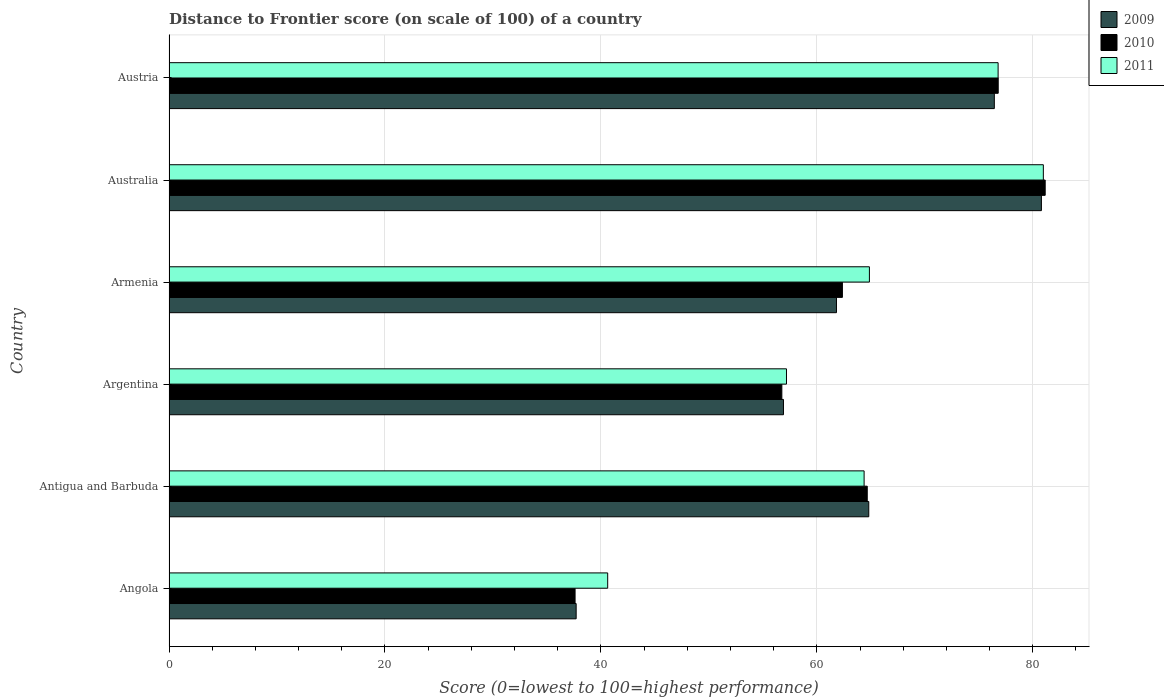How many groups of bars are there?
Keep it short and to the point. 6. What is the distance to frontier score of in 2009 in Armenia?
Your response must be concise. 61.82. Across all countries, what is the maximum distance to frontier score of in 2011?
Offer a terse response. 80.98. Across all countries, what is the minimum distance to frontier score of in 2009?
Offer a very short reply. 37.71. In which country was the distance to frontier score of in 2010 maximum?
Offer a very short reply. Australia. In which country was the distance to frontier score of in 2011 minimum?
Your answer should be compact. Angola. What is the total distance to frontier score of in 2011 in the graph?
Your answer should be compact. 384.84. What is the difference between the distance to frontier score of in 2011 in Angola and that in Antigua and Barbuda?
Give a very brief answer. -23.75. What is the difference between the distance to frontier score of in 2011 in Argentina and the distance to frontier score of in 2009 in Armenia?
Keep it short and to the point. -4.63. What is the average distance to frontier score of in 2009 per country?
Provide a short and direct response. 63.08. What is the difference between the distance to frontier score of in 2010 and distance to frontier score of in 2009 in Argentina?
Your response must be concise. -0.15. What is the ratio of the distance to frontier score of in 2011 in Antigua and Barbuda to that in Armenia?
Offer a very short reply. 0.99. Is the distance to frontier score of in 2011 in Armenia less than that in Austria?
Offer a terse response. Yes. Is the difference between the distance to frontier score of in 2010 in Angola and Armenia greater than the difference between the distance to frontier score of in 2009 in Angola and Armenia?
Keep it short and to the point. No. What is the difference between the highest and the second highest distance to frontier score of in 2009?
Your answer should be compact. 4.36. What is the difference between the highest and the lowest distance to frontier score of in 2011?
Ensure brevity in your answer.  40.35. In how many countries, is the distance to frontier score of in 2009 greater than the average distance to frontier score of in 2009 taken over all countries?
Your answer should be compact. 3. What does the 1st bar from the top in Angola represents?
Offer a very short reply. 2011. How many countries are there in the graph?
Make the answer very short. 6. What is the difference between two consecutive major ticks on the X-axis?
Keep it short and to the point. 20. Are the values on the major ticks of X-axis written in scientific E-notation?
Offer a terse response. No. Does the graph contain any zero values?
Ensure brevity in your answer.  No. What is the title of the graph?
Offer a terse response. Distance to Frontier score (on scale of 100) of a country. What is the label or title of the X-axis?
Provide a succinct answer. Score (0=lowest to 100=highest performance). What is the Score (0=lowest to 100=highest performance) of 2009 in Angola?
Keep it short and to the point. 37.71. What is the Score (0=lowest to 100=highest performance) in 2010 in Angola?
Your answer should be very brief. 37.61. What is the Score (0=lowest to 100=highest performance) in 2011 in Angola?
Make the answer very short. 40.63. What is the Score (0=lowest to 100=highest performance) of 2009 in Antigua and Barbuda?
Give a very brief answer. 64.81. What is the Score (0=lowest to 100=highest performance) of 2010 in Antigua and Barbuda?
Give a very brief answer. 64.67. What is the Score (0=lowest to 100=highest performance) in 2011 in Antigua and Barbuda?
Your answer should be very brief. 64.38. What is the Score (0=lowest to 100=highest performance) of 2009 in Argentina?
Offer a very short reply. 56.91. What is the Score (0=lowest to 100=highest performance) of 2010 in Argentina?
Your answer should be compact. 56.76. What is the Score (0=lowest to 100=highest performance) in 2011 in Argentina?
Your response must be concise. 57.19. What is the Score (0=lowest to 100=highest performance) in 2009 in Armenia?
Your answer should be compact. 61.82. What is the Score (0=lowest to 100=highest performance) in 2010 in Armenia?
Provide a short and direct response. 62.37. What is the Score (0=lowest to 100=highest performance) of 2011 in Armenia?
Provide a succinct answer. 64.87. What is the Score (0=lowest to 100=highest performance) in 2009 in Australia?
Offer a terse response. 80.8. What is the Score (0=lowest to 100=highest performance) of 2010 in Australia?
Ensure brevity in your answer.  81.15. What is the Score (0=lowest to 100=highest performance) of 2011 in Australia?
Your answer should be very brief. 80.98. What is the Score (0=lowest to 100=highest performance) in 2009 in Austria?
Offer a terse response. 76.44. What is the Score (0=lowest to 100=highest performance) of 2010 in Austria?
Ensure brevity in your answer.  76.8. What is the Score (0=lowest to 100=highest performance) in 2011 in Austria?
Make the answer very short. 76.79. Across all countries, what is the maximum Score (0=lowest to 100=highest performance) in 2009?
Offer a very short reply. 80.8. Across all countries, what is the maximum Score (0=lowest to 100=highest performance) of 2010?
Make the answer very short. 81.15. Across all countries, what is the maximum Score (0=lowest to 100=highest performance) in 2011?
Provide a succinct answer. 80.98. Across all countries, what is the minimum Score (0=lowest to 100=highest performance) of 2009?
Offer a very short reply. 37.71. Across all countries, what is the minimum Score (0=lowest to 100=highest performance) in 2010?
Ensure brevity in your answer.  37.61. Across all countries, what is the minimum Score (0=lowest to 100=highest performance) in 2011?
Offer a very short reply. 40.63. What is the total Score (0=lowest to 100=highest performance) in 2009 in the graph?
Keep it short and to the point. 378.49. What is the total Score (0=lowest to 100=highest performance) of 2010 in the graph?
Your response must be concise. 379.36. What is the total Score (0=lowest to 100=highest performance) of 2011 in the graph?
Offer a terse response. 384.84. What is the difference between the Score (0=lowest to 100=highest performance) in 2009 in Angola and that in Antigua and Barbuda?
Your answer should be compact. -27.1. What is the difference between the Score (0=lowest to 100=highest performance) of 2010 in Angola and that in Antigua and Barbuda?
Make the answer very short. -27.06. What is the difference between the Score (0=lowest to 100=highest performance) of 2011 in Angola and that in Antigua and Barbuda?
Provide a short and direct response. -23.75. What is the difference between the Score (0=lowest to 100=highest performance) of 2009 in Angola and that in Argentina?
Your answer should be very brief. -19.2. What is the difference between the Score (0=lowest to 100=highest performance) in 2010 in Angola and that in Argentina?
Give a very brief answer. -19.15. What is the difference between the Score (0=lowest to 100=highest performance) in 2011 in Angola and that in Argentina?
Provide a succinct answer. -16.56. What is the difference between the Score (0=lowest to 100=highest performance) in 2009 in Angola and that in Armenia?
Provide a short and direct response. -24.11. What is the difference between the Score (0=lowest to 100=highest performance) of 2010 in Angola and that in Armenia?
Give a very brief answer. -24.76. What is the difference between the Score (0=lowest to 100=highest performance) in 2011 in Angola and that in Armenia?
Your response must be concise. -24.24. What is the difference between the Score (0=lowest to 100=highest performance) in 2009 in Angola and that in Australia?
Offer a very short reply. -43.09. What is the difference between the Score (0=lowest to 100=highest performance) in 2010 in Angola and that in Australia?
Your answer should be compact. -43.54. What is the difference between the Score (0=lowest to 100=highest performance) in 2011 in Angola and that in Australia?
Ensure brevity in your answer.  -40.35. What is the difference between the Score (0=lowest to 100=highest performance) of 2009 in Angola and that in Austria?
Your response must be concise. -38.73. What is the difference between the Score (0=lowest to 100=highest performance) of 2010 in Angola and that in Austria?
Provide a short and direct response. -39.19. What is the difference between the Score (0=lowest to 100=highest performance) in 2011 in Angola and that in Austria?
Your response must be concise. -36.16. What is the difference between the Score (0=lowest to 100=highest performance) in 2010 in Antigua and Barbuda and that in Argentina?
Your answer should be very brief. 7.91. What is the difference between the Score (0=lowest to 100=highest performance) of 2011 in Antigua and Barbuda and that in Argentina?
Your response must be concise. 7.19. What is the difference between the Score (0=lowest to 100=highest performance) of 2009 in Antigua and Barbuda and that in Armenia?
Keep it short and to the point. 2.99. What is the difference between the Score (0=lowest to 100=highest performance) in 2010 in Antigua and Barbuda and that in Armenia?
Provide a succinct answer. 2.3. What is the difference between the Score (0=lowest to 100=highest performance) in 2011 in Antigua and Barbuda and that in Armenia?
Offer a very short reply. -0.49. What is the difference between the Score (0=lowest to 100=highest performance) in 2009 in Antigua and Barbuda and that in Australia?
Provide a short and direct response. -15.99. What is the difference between the Score (0=lowest to 100=highest performance) in 2010 in Antigua and Barbuda and that in Australia?
Provide a succinct answer. -16.48. What is the difference between the Score (0=lowest to 100=highest performance) of 2011 in Antigua and Barbuda and that in Australia?
Make the answer very short. -16.6. What is the difference between the Score (0=lowest to 100=highest performance) of 2009 in Antigua and Barbuda and that in Austria?
Make the answer very short. -11.63. What is the difference between the Score (0=lowest to 100=highest performance) of 2010 in Antigua and Barbuda and that in Austria?
Your answer should be compact. -12.13. What is the difference between the Score (0=lowest to 100=highest performance) in 2011 in Antigua and Barbuda and that in Austria?
Provide a short and direct response. -12.41. What is the difference between the Score (0=lowest to 100=highest performance) in 2009 in Argentina and that in Armenia?
Your answer should be compact. -4.91. What is the difference between the Score (0=lowest to 100=highest performance) of 2010 in Argentina and that in Armenia?
Your response must be concise. -5.61. What is the difference between the Score (0=lowest to 100=highest performance) of 2011 in Argentina and that in Armenia?
Make the answer very short. -7.68. What is the difference between the Score (0=lowest to 100=highest performance) in 2009 in Argentina and that in Australia?
Provide a short and direct response. -23.89. What is the difference between the Score (0=lowest to 100=highest performance) of 2010 in Argentina and that in Australia?
Provide a succinct answer. -24.39. What is the difference between the Score (0=lowest to 100=highest performance) of 2011 in Argentina and that in Australia?
Keep it short and to the point. -23.79. What is the difference between the Score (0=lowest to 100=highest performance) of 2009 in Argentina and that in Austria?
Offer a very short reply. -19.53. What is the difference between the Score (0=lowest to 100=highest performance) in 2010 in Argentina and that in Austria?
Your answer should be very brief. -20.04. What is the difference between the Score (0=lowest to 100=highest performance) of 2011 in Argentina and that in Austria?
Provide a succinct answer. -19.6. What is the difference between the Score (0=lowest to 100=highest performance) in 2009 in Armenia and that in Australia?
Your answer should be very brief. -18.98. What is the difference between the Score (0=lowest to 100=highest performance) in 2010 in Armenia and that in Australia?
Keep it short and to the point. -18.78. What is the difference between the Score (0=lowest to 100=highest performance) of 2011 in Armenia and that in Australia?
Your response must be concise. -16.11. What is the difference between the Score (0=lowest to 100=highest performance) of 2009 in Armenia and that in Austria?
Your answer should be compact. -14.62. What is the difference between the Score (0=lowest to 100=highest performance) in 2010 in Armenia and that in Austria?
Provide a succinct answer. -14.43. What is the difference between the Score (0=lowest to 100=highest performance) in 2011 in Armenia and that in Austria?
Ensure brevity in your answer.  -11.92. What is the difference between the Score (0=lowest to 100=highest performance) of 2009 in Australia and that in Austria?
Provide a succinct answer. 4.36. What is the difference between the Score (0=lowest to 100=highest performance) in 2010 in Australia and that in Austria?
Your answer should be very brief. 4.35. What is the difference between the Score (0=lowest to 100=highest performance) in 2011 in Australia and that in Austria?
Provide a short and direct response. 4.19. What is the difference between the Score (0=lowest to 100=highest performance) in 2009 in Angola and the Score (0=lowest to 100=highest performance) in 2010 in Antigua and Barbuda?
Your answer should be very brief. -26.96. What is the difference between the Score (0=lowest to 100=highest performance) of 2009 in Angola and the Score (0=lowest to 100=highest performance) of 2011 in Antigua and Barbuda?
Give a very brief answer. -26.67. What is the difference between the Score (0=lowest to 100=highest performance) of 2010 in Angola and the Score (0=lowest to 100=highest performance) of 2011 in Antigua and Barbuda?
Offer a terse response. -26.77. What is the difference between the Score (0=lowest to 100=highest performance) in 2009 in Angola and the Score (0=lowest to 100=highest performance) in 2010 in Argentina?
Make the answer very short. -19.05. What is the difference between the Score (0=lowest to 100=highest performance) of 2009 in Angola and the Score (0=lowest to 100=highest performance) of 2011 in Argentina?
Give a very brief answer. -19.48. What is the difference between the Score (0=lowest to 100=highest performance) of 2010 in Angola and the Score (0=lowest to 100=highest performance) of 2011 in Argentina?
Give a very brief answer. -19.58. What is the difference between the Score (0=lowest to 100=highest performance) in 2009 in Angola and the Score (0=lowest to 100=highest performance) in 2010 in Armenia?
Provide a succinct answer. -24.66. What is the difference between the Score (0=lowest to 100=highest performance) in 2009 in Angola and the Score (0=lowest to 100=highest performance) in 2011 in Armenia?
Offer a terse response. -27.16. What is the difference between the Score (0=lowest to 100=highest performance) in 2010 in Angola and the Score (0=lowest to 100=highest performance) in 2011 in Armenia?
Offer a terse response. -27.26. What is the difference between the Score (0=lowest to 100=highest performance) of 2009 in Angola and the Score (0=lowest to 100=highest performance) of 2010 in Australia?
Offer a very short reply. -43.44. What is the difference between the Score (0=lowest to 100=highest performance) of 2009 in Angola and the Score (0=lowest to 100=highest performance) of 2011 in Australia?
Keep it short and to the point. -43.27. What is the difference between the Score (0=lowest to 100=highest performance) in 2010 in Angola and the Score (0=lowest to 100=highest performance) in 2011 in Australia?
Make the answer very short. -43.37. What is the difference between the Score (0=lowest to 100=highest performance) of 2009 in Angola and the Score (0=lowest to 100=highest performance) of 2010 in Austria?
Ensure brevity in your answer.  -39.09. What is the difference between the Score (0=lowest to 100=highest performance) in 2009 in Angola and the Score (0=lowest to 100=highest performance) in 2011 in Austria?
Your answer should be compact. -39.08. What is the difference between the Score (0=lowest to 100=highest performance) in 2010 in Angola and the Score (0=lowest to 100=highest performance) in 2011 in Austria?
Ensure brevity in your answer.  -39.18. What is the difference between the Score (0=lowest to 100=highest performance) in 2009 in Antigua and Barbuda and the Score (0=lowest to 100=highest performance) in 2010 in Argentina?
Give a very brief answer. 8.05. What is the difference between the Score (0=lowest to 100=highest performance) in 2009 in Antigua and Barbuda and the Score (0=lowest to 100=highest performance) in 2011 in Argentina?
Provide a succinct answer. 7.62. What is the difference between the Score (0=lowest to 100=highest performance) of 2010 in Antigua and Barbuda and the Score (0=lowest to 100=highest performance) of 2011 in Argentina?
Give a very brief answer. 7.48. What is the difference between the Score (0=lowest to 100=highest performance) of 2009 in Antigua and Barbuda and the Score (0=lowest to 100=highest performance) of 2010 in Armenia?
Keep it short and to the point. 2.44. What is the difference between the Score (0=lowest to 100=highest performance) of 2009 in Antigua and Barbuda and the Score (0=lowest to 100=highest performance) of 2011 in Armenia?
Give a very brief answer. -0.06. What is the difference between the Score (0=lowest to 100=highest performance) in 2010 in Antigua and Barbuda and the Score (0=lowest to 100=highest performance) in 2011 in Armenia?
Ensure brevity in your answer.  -0.2. What is the difference between the Score (0=lowest to 100=highest performance) in 2009 in Antigua and Barbuda and the Score (0=lowest to 100=highest performance) in 2010 in Australia?
Offer a very short reply. -16.34. What is the difference between the Score (0=lowest to 100=highest performance) in 2009 in Antigua and Barbuda and the Score (0=lowest to 100=highest performance) in 2011 in Australia?
Make the answer very short. -16.17. What is the difference between the Score (0=lowest to 100=highest performance) of 2010 in Antigua and Barbuda and the Score (0=lowest to 100=highest performance) of 2011 in Australia?
Provide a short and direct response. -16.31. What is the difference between the Score (0=lowest to 100=highest performance) of 2009 in Antigua and Barbuda and the Score (0=lowest to 100=highest performance) of 2010 in Austria?
Provide a succinct answer. -11.99. What is the difference between the Score (0=lowest to 100=highest performance) of 2009 in Antigua and Barbuda and the Score (0=lowest to 100=highest performance) of 2011 in Austria?
Ensure brevity in your answer.  -11.98. What is the difference between the Score (0=lowest to 100=highest performance) of 2010 in Antigua and Barbuda and the Score (0=lowest to 100=highest performance) of 2011 in Austria?
Provide a succinct answer. -12.12. What is the difference between the Score (0=lowest to 100=highest performance) of 2009 in Argentina and the Score (0=lowest to 100=highest performance) of 2010 in Armenia?
Make the answer very short. -5.46. What is the difference between the Score (0=lowest to 100=highest performance) in 2009 in Argentina and the Score (0=lowest to 100=highest performance) in 2011 in Armenia?
Your answer should be very brief. -7.96. What is the difference between the Score (0=lowest to 100=highest performance) in 2010 in Argentina and the Score (0=lowest to 100=highest performance) in 2011 in Armenia?
Offer a terse response. -8.11. What is the difference between the Score (0=lowest to 100=highest performance) of 2009 in Argentina and the Score (0=lowest to 100=highest performance) of 2010 in Australia?
Keep it short and to the point. -24.24. What is the difference between the Score (0=lowest to 100=highest performance) of 2009 in Argentina and the Score (0=lowest to 100=highest performance) of 2011 in Australia?
Keep it short and to the point. -24.07. What is the difference between the Score (0=lowest to 100=highest performance) in 2010 in Argentina and the Score (0=lowest to 100=highest performance) in 2011 in Australia?
Provide a succinct answer. -24.22. What is the difference between the Score (0=lowest to 100=highest performance) of 2009 in Argentina and the Score (0=lowest to 100=highest performance) of 2010 in Austria?
Keep it short and to the point. -19.89. What is the difference between the Score (0=lowest to 100=highest performance) in 2009 in Argentina and the Score (0=lowest to 100=highest performance) in 2011 in Austria?
Give a very brief answer. -19.88. What is the difference between the Score (0=lowest to 100=highest performance) in 2010 in Argentina and the Score (0=lowest to 100=highest performance) in 2011 in Austria?
Keep it short and to the point. -20.03. What is the difference between the Score (0=lowest to 100=highest performance) in 2009 in Armenia and the Score (0=lowest to 100=highest performance) in 2010 in Australia?
Offer a very short reply. -19.33. What is the difference between the Score (0=lowest to 100=highest performance) in 2009 in Armenia and the Score (0=lowest to 100=highest performance) in 2011 in Australia?
Provide a succinct answer. -19.16. What is the difference between the Score (0=lowest to 100=highest performance) in 2010 in Armenia and the Score (0=lowest to 100=highest performance) in 2011 in Australia?
Offer a very short reply. -18.61. What is the difference between the Score (0=lowest to 100=highest performance) in 2009 in Armenia and the Score (0=lowest to 100=highest performance) in 2010 in Austria?
Provide a succinct answer. -14.98. What is the difference between the Score (0=lowest to 100=highest performance) of 2009 in Armenia and the Score (0=lowest to 100=highest performance) of 2011 in Austria?
Keep it short and to the point. -14.97. What is the difference between the Score (0=lowest to 100=highest performance) in 2010 in Armenia and the Score (0=lowest to 100=highest performance) in 2011 in Austria?
Offer a terse response. -14.42. What is the difference between the Score (0=lowest to 100=highest performance) of 2009 in Australia and the Score (0=lowest to 100=highest performance) of 2011 in Austria?
Make the answer very short. 4.01. What is the difference between the Score (0=lowest to 100=highest performance) in 2010 in Australia and the Score (0=lowest to 100=highest performance) in 2011 in Austria?
Offer a terse response. 4.36. What is the average Score (0=lowest to 100=highest performance) of 2009 per country?
Provide a short and direct response. 63.08. What is the average Score (0=lowest to 100=highest performance) in 2010 per country?
Give a very brief answer. 63.23. What is the average Score (0=lowest to 100=highest performance) in 2011 per country?
Your answer should be compact. 64.14. What is the difference between the Score (0=lowest to 100=highest performance) of 2009 and Score (0=lowest to 100=highest performance) of 2011 in Angola?
Your answer should be compact. -2.92. What is the difference between the Score (0=lowest to 100=highest performance) of 2010 and Score (0=lowest to 100=highest performance) of 2011 in Angola?
Ensure brevity in your answer.  -3.02. What is the difference between the Score (0=lowest to 100=highest performance) of 2009 and Score (0=lowest to 100=highest performance) of 2010 in Antigua and Barbuda?
Offer a terse response. 0.14. What is the difference between the Score (0=lowest to 100=highest performance) in 2009 and Score (0=lowest to 100=highest performance) in 2011 in Antigua and Barbuda?
Your response must be concise. 0.43. What is the difference between the Score (0=lowest to 100=highest performance) in 2010 and Score (0=lowest to 100=highest performance) in 2011 in Antigua and Barbuda?
Give a very brief answer. 0.29. What is the difference between the Score (0=lowest to 100=highest performance) of 2009 and Score (0=lowest to 100=highest performance) of 2010 in Argentina?
Your response must be concise. 0.15. What is the difference between the Score (0=lowest to 100=highest performance) of 2009 and Score (0=lowest to 100=highest performance) of 2011 in Argentina?
Your answer should be very brief. -0.28. What is the difference between the Score (0=lowest to 100=highest performance) in 2010 and Score (0=lowest to 100=highest performance) in 2011 in Argentina?
Give a very brief answer. -0.43. What is the difference between the Score (0=lowest to 100=highest performance) of 2009 and Score (0=lowest to 100=highest performance) of 2010 in Armenia?
Give a very brief answer. -0.55. What is the difference between the Score (0=lowest to 100=highest performance) of 2009 and Score (0=lowest to 100=highest performance) of 2011 in Armenia?
Give a very brief answer. -3.05. What is the difference between the Score (0=lowest to 100=highest performance) in 2009 and Score (0=lowest to 100=highest performance) in 2010 in Australia?
Make the answer very short. -0.35. What is the difference between the Score (0=lowest to 100=highest performance) in 2009 and Score (0=lowest to 100=highest performance) in 2011 in Australia?
Offer a terse response. -0.18. What is the difference between the Score (0=lowest to 100=highest performance) of 2010 and Score (0=lowest to 100=highest performance) of 2011 in Australia?
Your response must be concise. 0.17. What is the difference between the Score (0=lowest to 100=highest performance) of 2009 and Score (0=lowest to 100=highest performance) of 2010 in Austria?
Offer a very short reply. -0.36. What is the difference between the Score (0=lowest to 100=highest performance) in 2009 and Score (0=lowest to 100=highest performance) in 2011 in Austria?
Provide a succinct answer. -0.35. What is the difference between the Score (0=lowest to 100=highest performance) in 2010 and Score (0=lowest to 100=highest performance) in 2011 in Austria?
Ensure brevity in your answer.  0.01. What is the ratio of the Score (0=lowest to 100=highest performance) of 2009 in Angola to that in Antigua and Barbuda?
Your answer should be very brief. 0.58. What is the ratio of the Score (0=lowest to 100=highest performance) of 2010 in Angola to that in Antigua and Barbuda?
Offer a very short reply. 0.58. What is the ratio of the Score (0=lowest to 100=highest performance) in 2011 in Angola to that in Antigua and Barbuda?
Offer a terse response. 0.63. What is the ratio of the Score (0=lowest to 100=highest performance) in 2009 in Angola to that in Argentina?
Give a very brief answer. 0.66. What is the ratio of the Score (0=lowest to 100=highest performance) in 2010 in Angola to that in Argentina?
Give a very brief answer. 0.66. What is the ratio of the Score (0=lowest to 100=highest performance) in 2011 in Angola to that in Argentina?
Give a very brief answer. 0.71. What is the ratio of the Score (0=lowest to 100=highest performance) in 2009 in Angola to that in Armenia?
Provide a short and direct response. 0.61. What is the ratio of the Score (0=lowest to 100=highest performance) in 2010 in Angola to that in Armenia?
Keep it short and to the point. 0.6. What is the ratio of the Score (0=lowest to 100=highest performance) in 2011 in Angola to that in Armenia?
Ensure brevity in your answer.  0.63. What is the ratio of the Score (0=lowest to 100=highest performance) of 2009 in Angola to that in Australia?
Offer a very short reply. 0.47. What is the ratio of the Score (0=lowest to 100=highest performance) of 2010 in Angola to that in Australia?
Offer a very short reply. 0.46. What is the ratio of the Score (0=lowest to 100=highest performance) in 2011 in Angola to that in Australia?
Provide a succinct answer. 0.5. What is the ratio of the Score (0=lowest to 100=highest performance) of 2009 in Angola to that in Austria?
Offer a very short reply. 0.49. What is the ratio of the Score (0=lowest to 100=highest performance) in 2010 in Angola to that in Austria?
Offer a terse response. 0.49. What is the ratio of the Score (0=lowest to 100=highest performance) of 2011 in Angola to that in Austria?
Keep it short and to the point. 0.53. What is the ratio of the Score (0=lowest to 100=highest performance) of 2009 in Antigua and Barbuda to that in Argentina?
Provide a succinct answer. 1.14. What is the ratio of the Score (0=lowest to 100=highest performance) in 2010 in Antigua and Barbuda to that in Argentina?
Your response must be concise. 1.14. What is the ratio of the Score (0=lowest to 100=highest performance) of 2011 in Antigua and Barbuda to that in Argentina?
Your answer should be very brief. 1.13. What is the ratio of the Score (0=lowest to 100=highest performance) in 2009 in Antigua and Barbuda to that in Armenia?
Your answer should be very brief. 1.05. What is the ratio of the Score (0=lowest to 100=highest performance) of 2010 in Antigua and Barbuda to that in Armenia?
Your answer should be very brief. 1.04. What is the ratio of the Score (0=lowest to 100=highest performance) of 2011 in Antigua and Barbuda to that in Armenia?
Offer a terse response. 0.99. What is the ratio of the Score (0=lowest to 100=highest performance) in 2009 in Antigua and Barbuda to that in Australia?
Ensure brevity in your answer.  0.8. What is the ratio of the Score (0=lowest to 100=highest performance) in 2010 in Antigua and Barbuda to that in Australia?
Offer a very short reply. 0.8. What is the ratio of the Score (0=lowest to 100=highest performance) in 2011 in Antigua and Barbuda to that in Australia?
Ensure brevity in your answer.  0.8. What is the ratio of the Score (0=lowest to 100=highest performance) in 2009 in Antigua and Barbuda to that in Austria?
Ensure brevity in your answer.  0.85. What is the ratio of the Score (0=lowest to 100=highest performance) in 2010 in Antigua and Barbuda to that in Austria?
Offer a very short reply. 0.84. What is the ratio of the Score (0=lowest to 100=highest performance) in 2011 in Antigua and Barbuda to that in Austria?
Your answer should be compact. 0.84. What is the ratio of the Score (0=lowest to 100=highest performance) in 2009 in Argentina to that in Armenia?
Your answer should be compact. 0.92. What is the ratio of the Score (0=lowest to 100=highest performance) in 2010 in Argentina to that in Armenia?
Ensure brevity in your answer.  0.91. What is the ratio of the Score (0=lowest to 100=highest performance) in 2011 in Argentina to that in Armenia?
Make the answer very short. 0.88. What is the ratio of the Score (0=lowest to 100=highest performance) of 2009 in Argentina to that in Australia?
Make the answer very short. 0.7. What is the ratio of the Score (0=lowest to 100=highest performance) in 2010 in Argentina to that in Australia?
Offer a terse response. 0.7. What is the ratio of the Score (0=lowest to 100=highest performance) of 2011 in Argentina to that in Australia?
Your answer should be compact. 0.71. What is the ratio of the Score (0=lowest to 100=highest performance) of 2009 in Argentina to that in Austria?
Your answer should be compact. 0.74. What is the ratio of the Score (0=lowest to 100=highest performance) of 2010 in Argentina to that in Austria?
Your answer should be compact. 0.74. What is the ratio of the Score (0=lowest to 100=highest performance) in 2011 in Argentina to that in Austria?
Keep it short and to the point. 0.74. What is the ratio of the Score (0=lowest to 100=highest performance) of 2009 in Armenia to that in Australia?
Give a very brief answer. 0.77. What is the ratio of the Score (0=lowest to 100=highest performance) of 2010 in Armenia to that in Australia?
Your answer should be very brief. 0.77. What is the ratio of the Score (0=lowest to 100=highest performance) of 2011 in Armenia to that in Australia?
Offer a terse response. 0.8. What is the ratio of the Score (0=lowest to 100=highest performance) in 2009 in Armenia to that in Austria?
Ensure brevity in your answer.  0.81. What is the ratio of the Score (0=lowest to 100=highest performance) in 2010 in Armenia to that in Austria?
Provide a succinct answer. 0.81. What is the ratio of the Score (0=lowest to 100=highest performance) of 2011 in Armenia to that in Austria?
Offer a very short reply. 0.84. What is the ratio of the Score (0=lowest to 100=highest performance) in 2009 in Australia to that in Austria?
Give a very brief answer. 1.06. What is the ratio of the Score (0=lowest to 100=highest performance) in 2010 in Australia to that in Austria?
Provide a succinct answer. 1.06. What is the ratio of the Score (0=lowest to 100=highest performance) in 2011 in Australia to that in Austria?
Provide a short and direct response. 1.05. What is the difference between the highest and the second highest Score (0=lowest to 100=highest performance) of 2009?
Provide a short and direct response. 4.36. What is the difference between the highest and the second highest Score (0=lowest to 100=highest performance) in 2010?
Your answer should be compact. 4.35. What is the difference between the highest and the second highest Score (0=lowest to 100=highest performance) in 2011?
Ensure brevity in your answer.  4.19. What is the difference between the highest and the lowest Score (0=lowest to 100=highest performance) of 2009?
Offer a terse response. 43.09. What is the difference between the highest and the lowest Score (0=lowest to 100=highest performance) of 2010?
Keep it short and to the point. 43.54. What is the difference between the highest and the lowest Score (0=lowest to 100=highest performance) of 2011?
Provide a succinct answer. 40.35. 